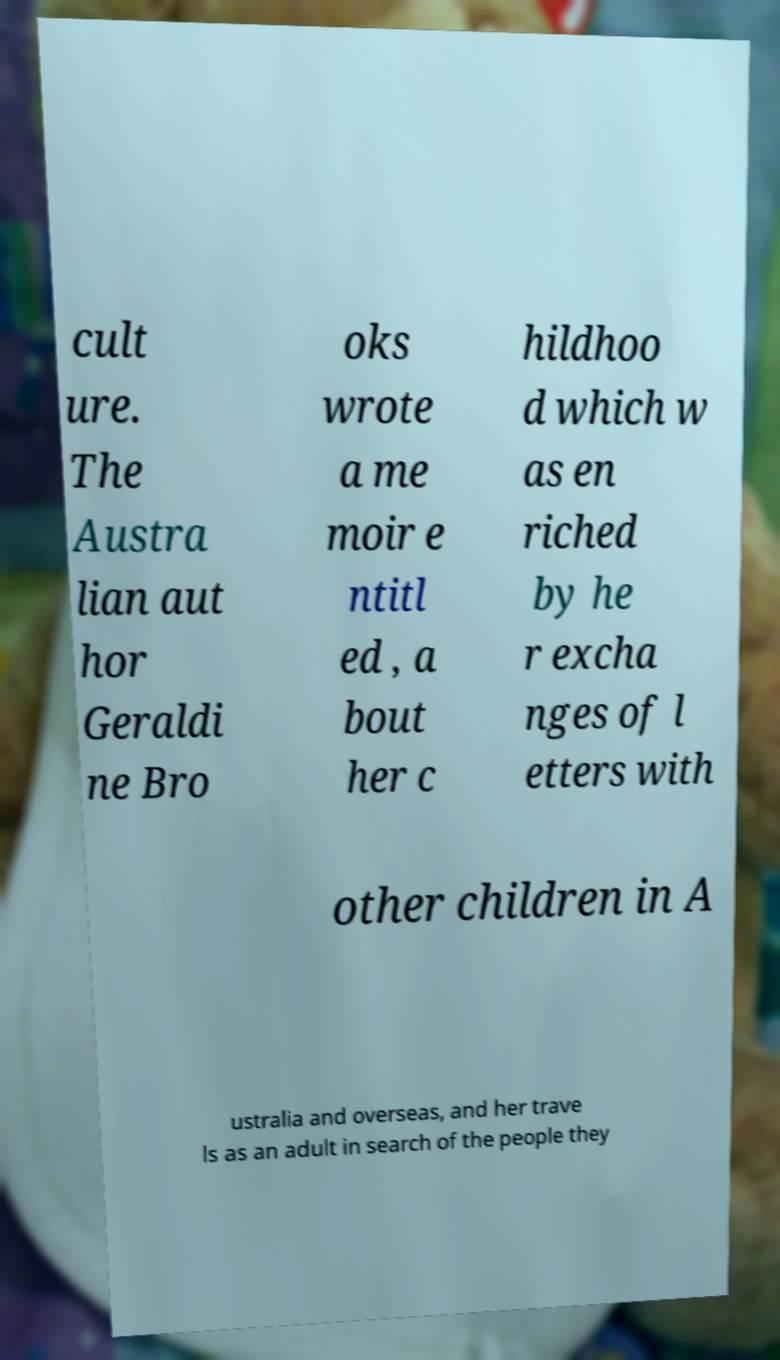Please read and relay the text visible in this image. What does it say? cult ure. The Austra lian aut hor Geraldi ne Bro oks wrote a me moir e ntitl ed , a bout her c hildhoo d which w as en riched by he r excha nges of l etters with other children in A ustralia and overseas, and her trave ls as an adult in search of the people they 